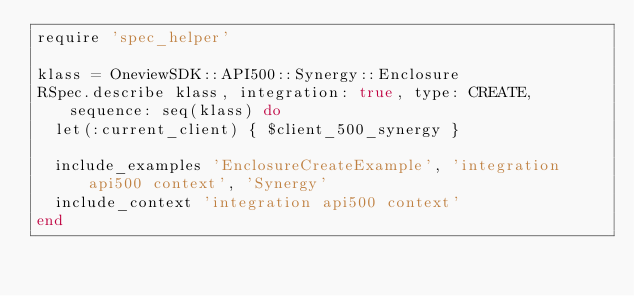Convert code to text. <code><loc_0><loc_0><loc_500><loc_500><_Ruby_>require 'spec_helper'

klass = OneviewSDK::API500::Synergy::Enclosure
RSpec.describe klass, integration: true, type: CREATE, sequence: seq(klass) do
  let(:current_client) { $client_500_synergy }

  include_examples 'EnclosureCreateExample', 'integration api500 context', 'Synergy'
  include_context 'integration api500 context'
end
</code> 